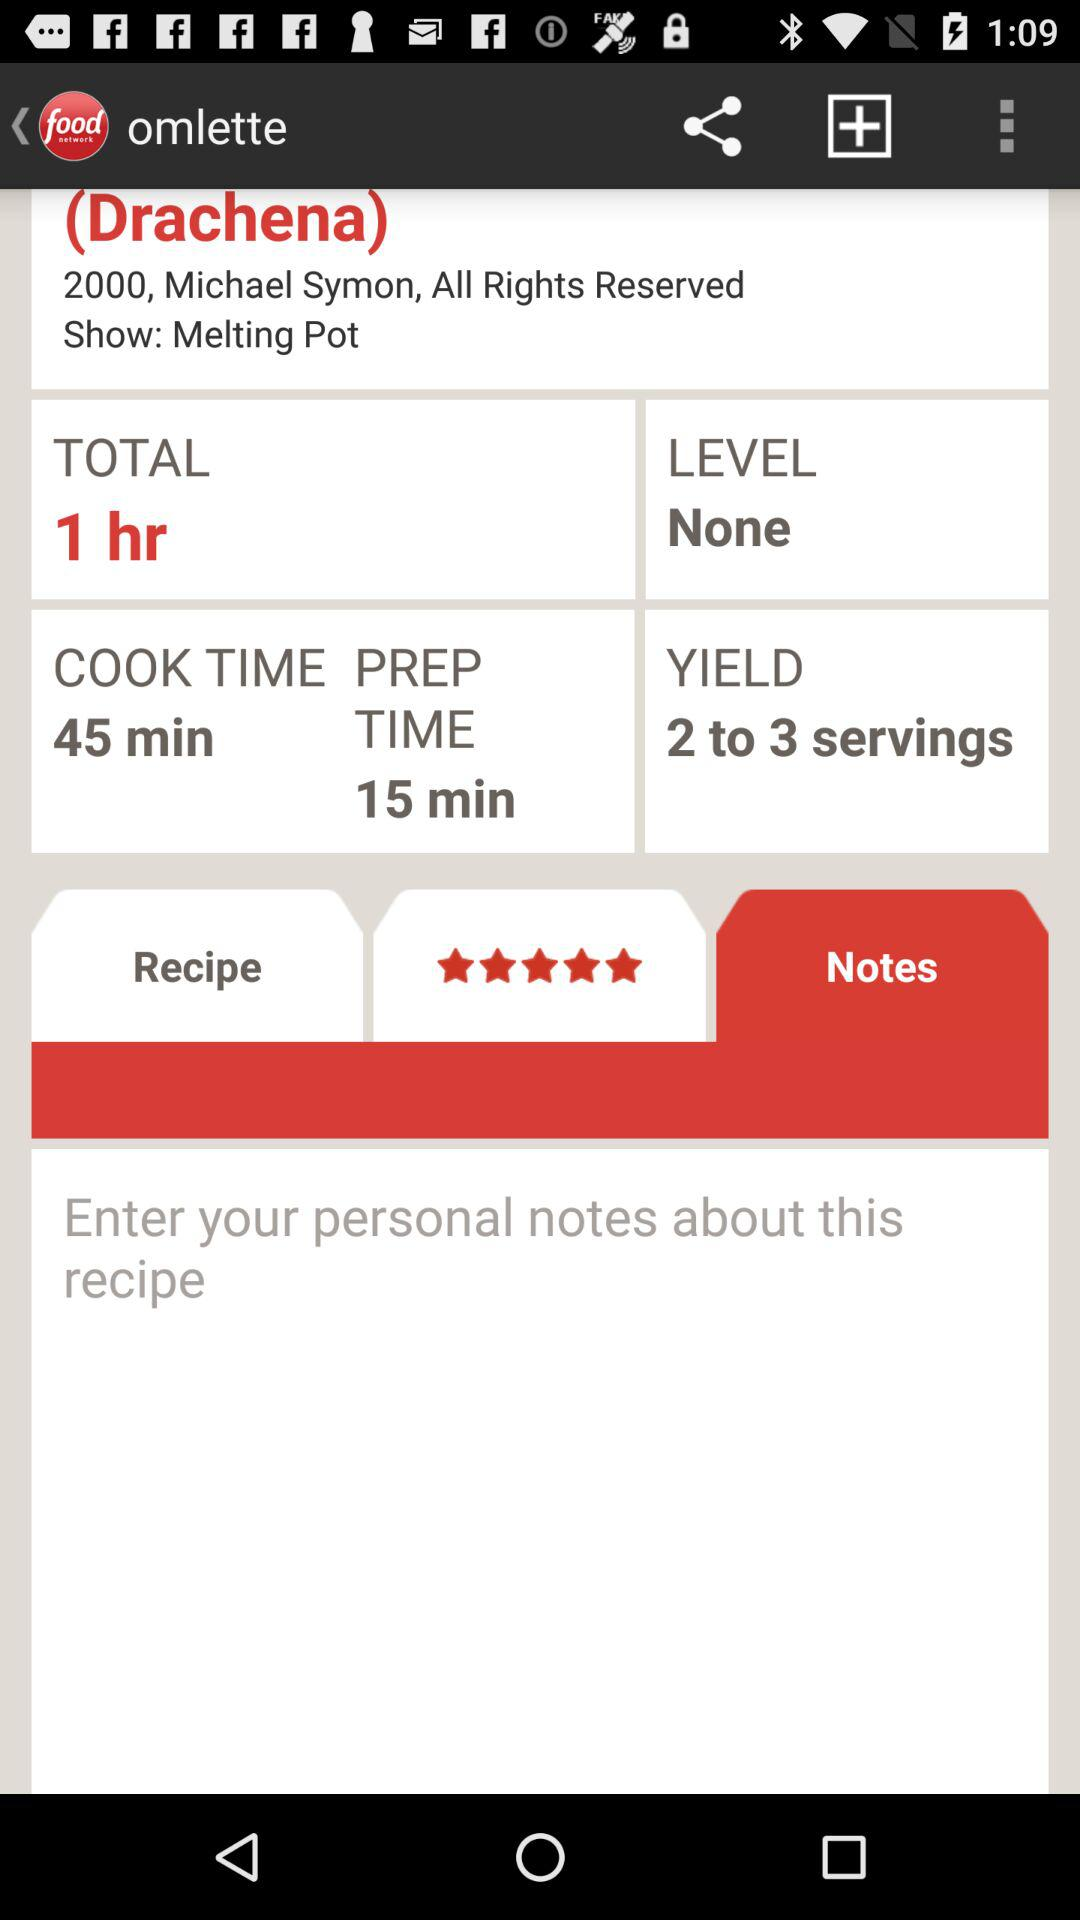How many servings will this recipe yield? This recipe will yield 2 to 3 servings. 